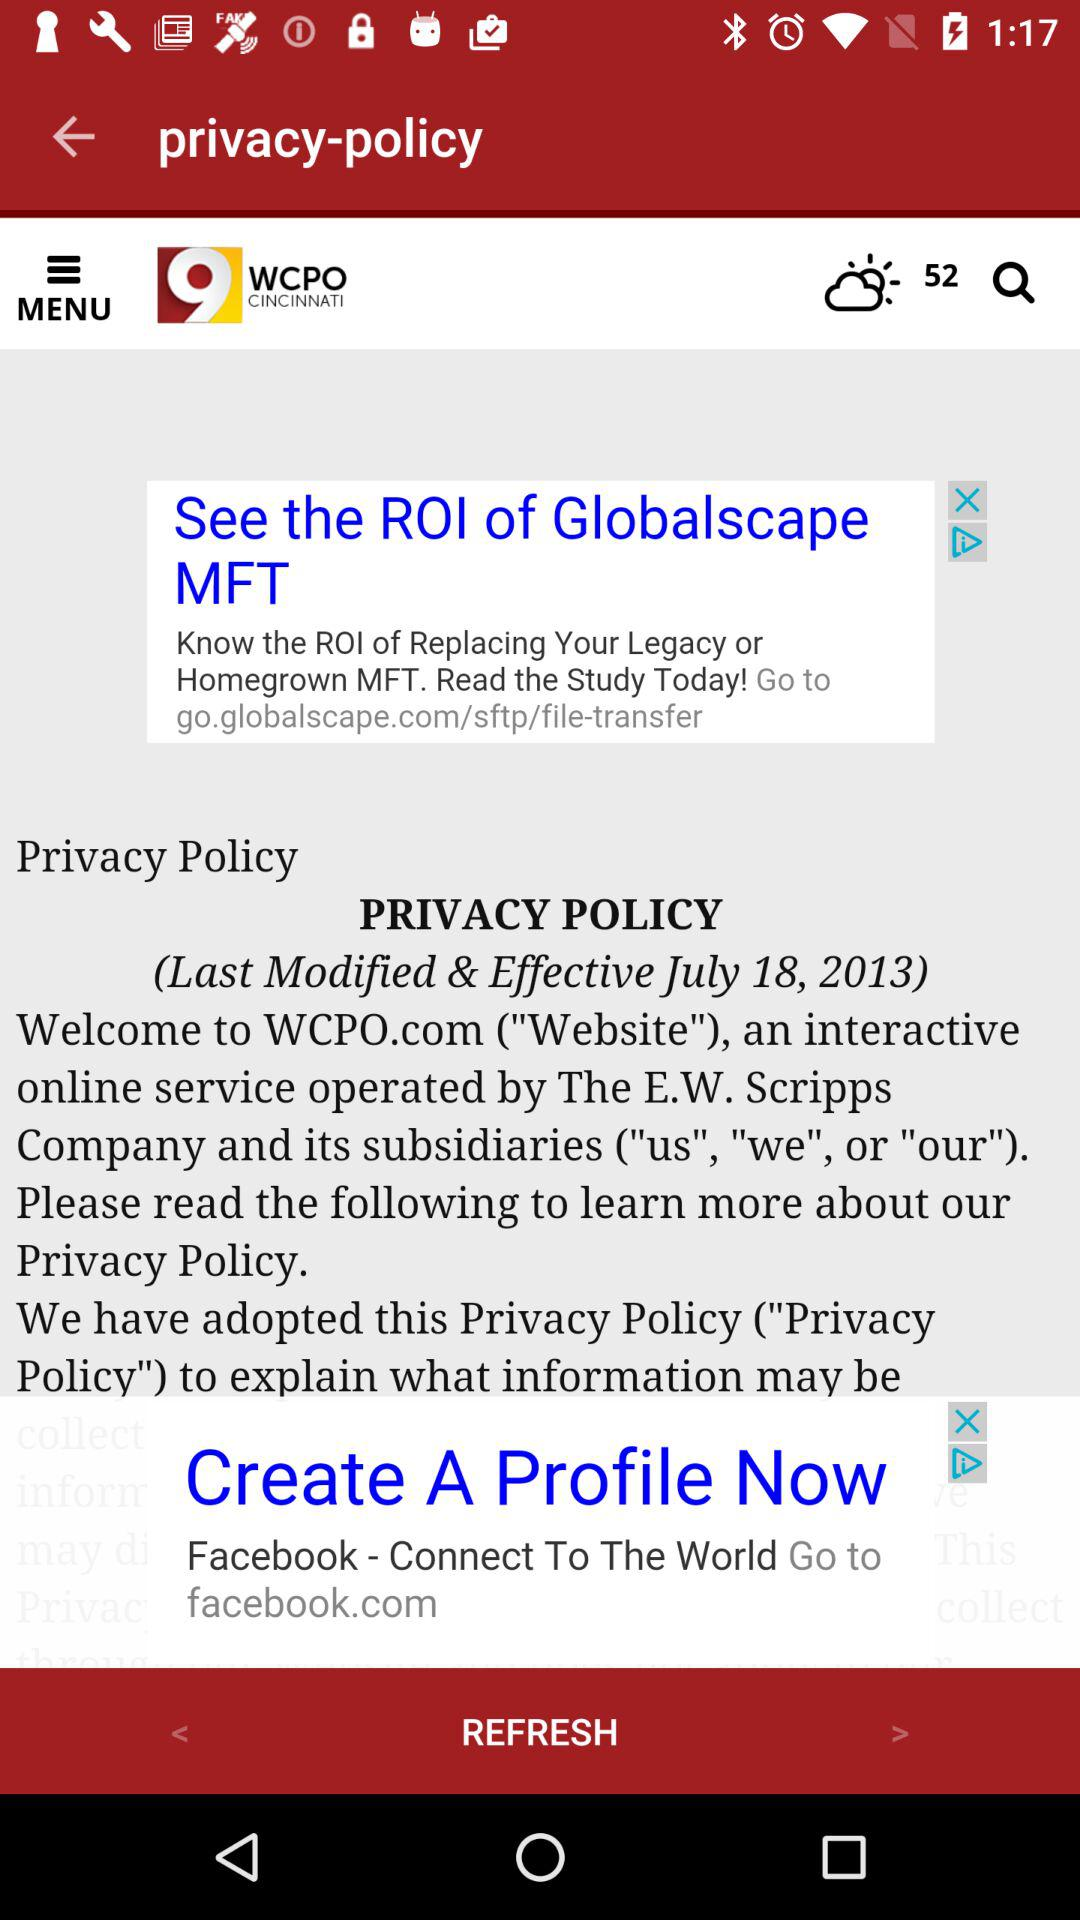What is the last modified date? The last modified date is July 18, 2013. 